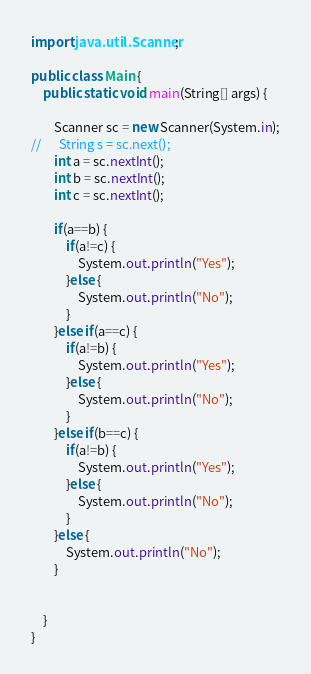<code> <loc_0><loc_0><loc_500><loc_500><_Java_>import java.util.Scanner;

public class Main {
	public static void main(String[] args) {

		Scanner sc = new Scanner(System.in);
//		String s = sc.next();
		int a = sc.nextInt();
		int b = sc.nextInt();
		int c = sc.nextInt();

		if(a==b) {
			if(a!=c) {
				System.out.println("Yes");
			}else {
				System.out.println("No");
			}
		}else if(a==c) {
			if(a!=b) {
				System.out.println("Yes");
			}else {
				System.out.println("No");
			}
		}else if(b==c) {
			if(a!=b) {
				System.out.println("Yes");
			}else {
				System.out.println("No");
			}
		}else {
			System.out.println("No");
		}


	}
}
</code> 